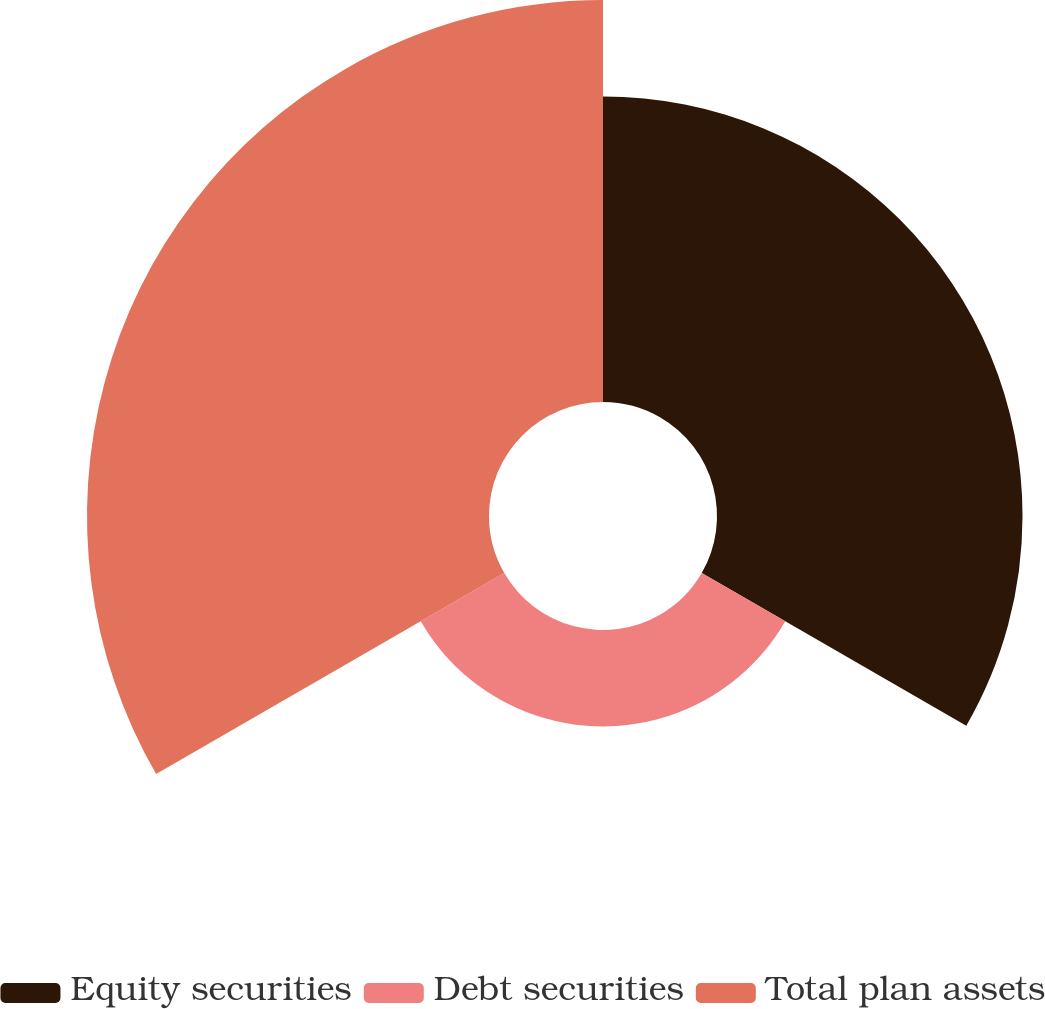Convert chart. <chart><loc_0><loc_0><loc_500><loc_500><pie_chart><fcel>Equity securities<fcel>Debt securities<fcel>Total plan assets<nl><fcel>38.0%<fcel>12.0%<fcel>50.0%<nl></chart> 